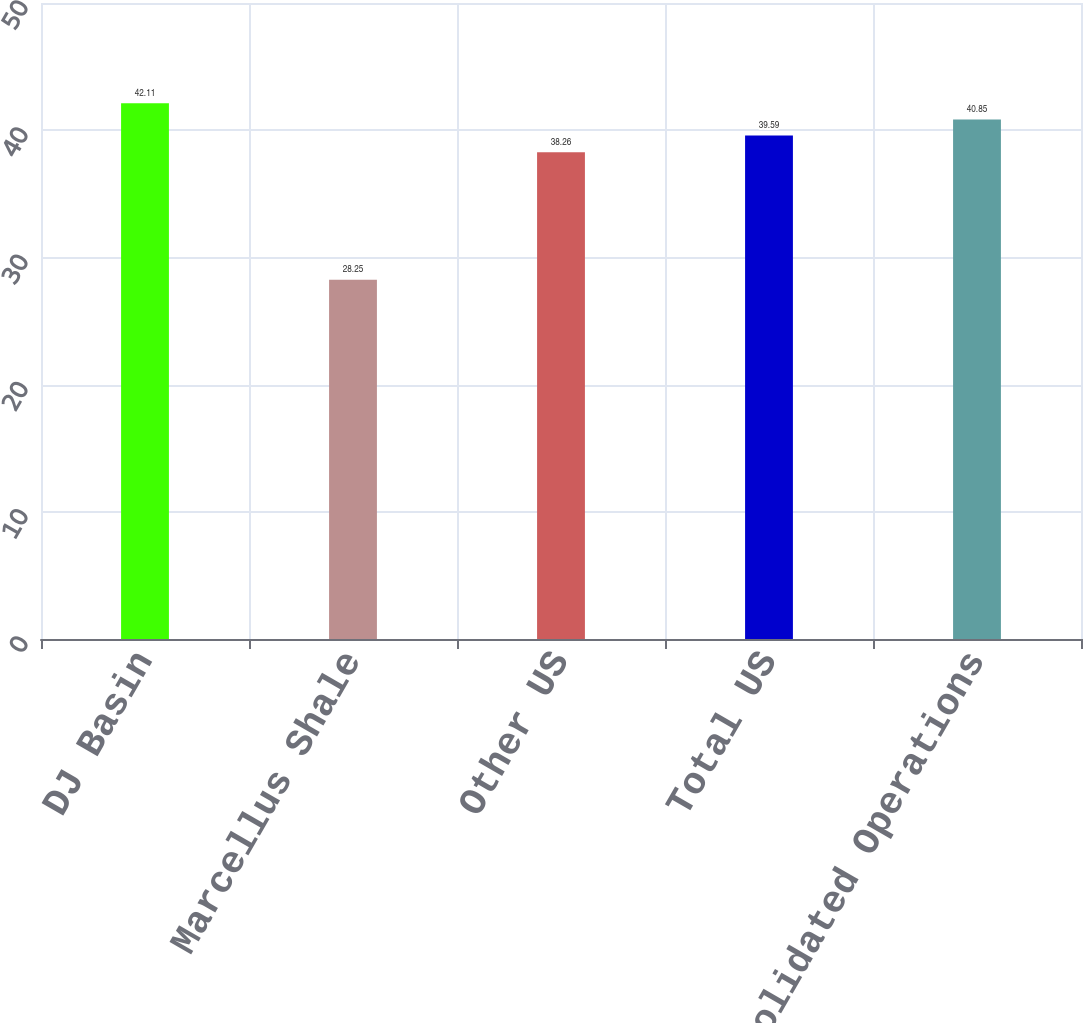Convert chart. <chart><loc_0><loc_0><loc_500><loc_500><bar_chart><fcel>DJ Basin<fcel>Marcellus Shale<fcel>Other US<fcel>Total US<fcel>Total Consolidated Operations<nl><fcel>42.11<fcel>28.25<fcel>38.26<fcel>39.59<fcel>40.85<nl></chart> 